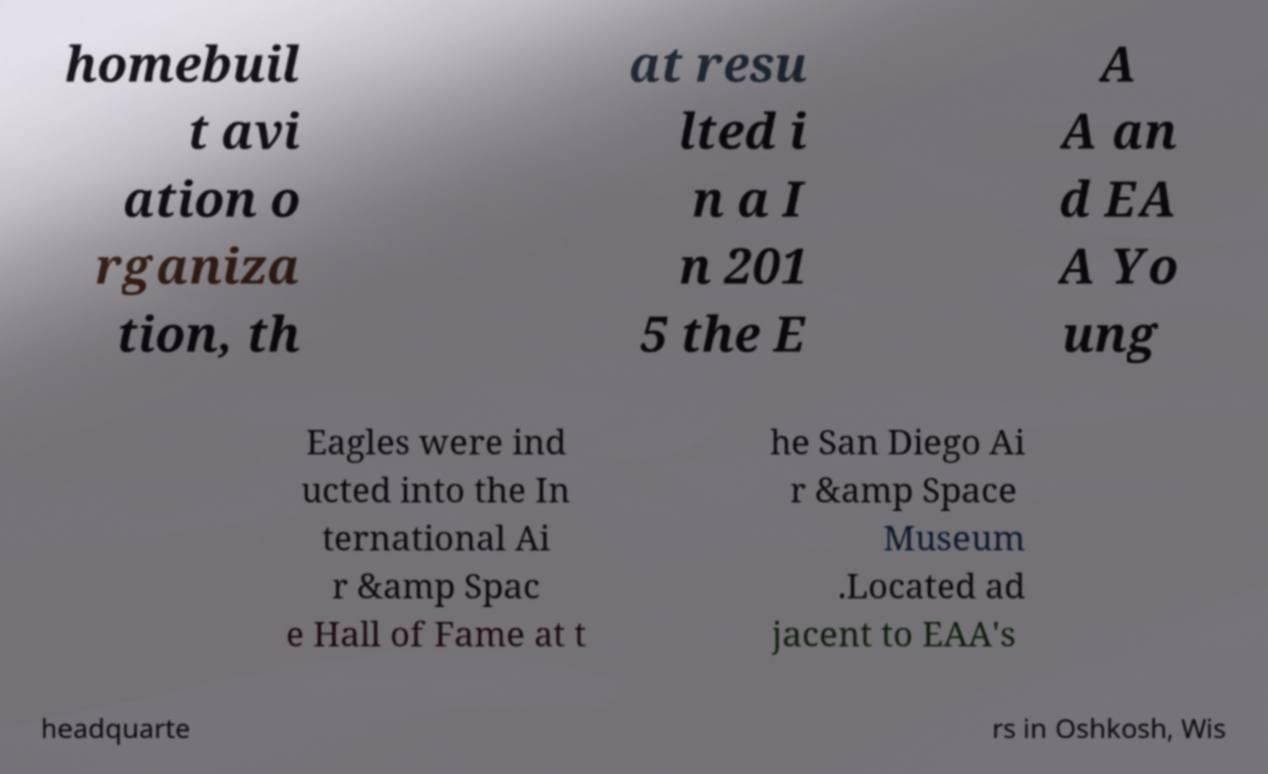I need the written content from this picture converted into text. Can you do that? homebuil t avi ation o rganiza tion, th at resu lted i n a I n 201 5 the E A A an d EA A Yo ung Eagles were ind ucted into the In ternational Ai r &amp Spac e Hall of Fame at t he San Diego Ai r &amp Space Museum .Located ad jacent to EAA's headquarte rs in Oshkosh, Wis 